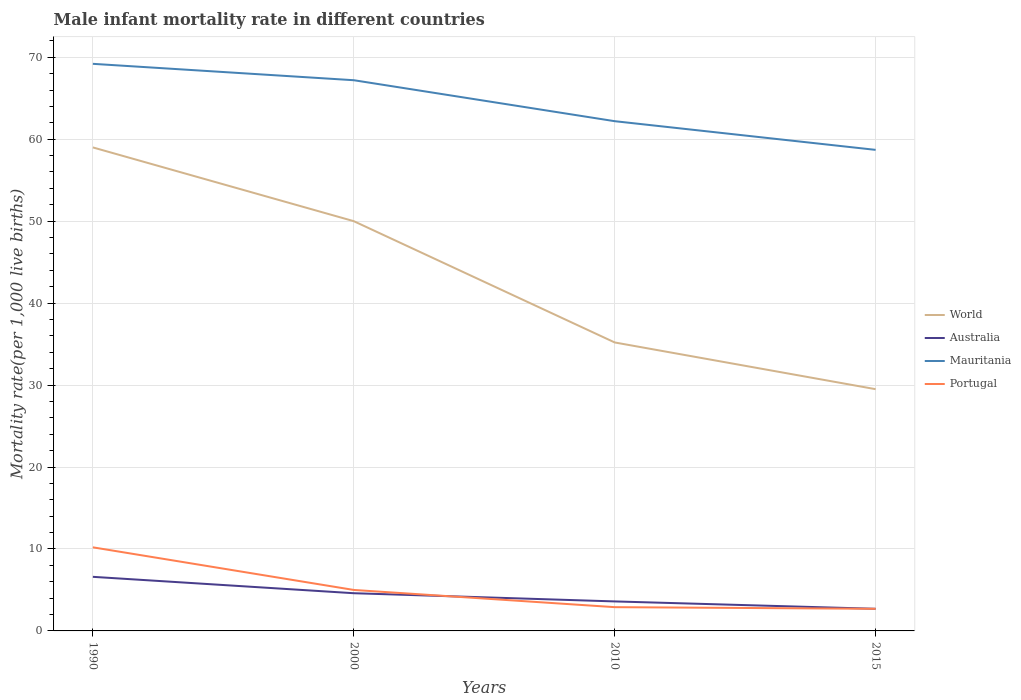How many different coloured lines are there?
Provide a succinct answer. 4. Does the line corresponding to World intersect with the line corresponding to Mauritania?
Offer a terse response. No. Across all years, what is the maximum male infant mortality rate in World?
Your answer should be compact. 29.5. In which year was the male infant mortality rate in Mauritania maximum?
Make the answer very short. 2015. What is the total male infant mortality rate in World in the graph?
Give a very brief answer. 14.8. What is the difference between the highest and the second highest male infant mortality rate in World?
Offer a terse response. 29.5. What is the difference between the highest and the lowest male infant mortality rate in Australia?
Make the answer very short. 2. How many years are there in the graph?
Keep it short and to the point. 4. What is the difference between two consecutive major ticks on the Y-axis?
Provide a short and direct response. 10. Does the graph contain any zero values?
Provide a succinct answer. No. What is the title of the graph?
Keep it short and to the point. Male infant mortality rate in different countries. Does "Gabon" appear as one of the legend labels in the graph?
Your answer should be compact. No. What is the label or title of the Y-axis?
Provide a short and direct response. Mortality rate(per 1,0 live births). What is the Mortality rate(per 1,000 live births) in World in 1990?
Your response must be concise. 59. What is the Mortality rate(per 1,000 live births) in Australia in 1990?
Offer a very short reply. 6.6. What is the Mortality rate(per 1,000 live births) of Mauritania in 1990?
Ensure brevity in your answer.  69.2. What is the Mortality rate(per 1,000 live births) of World in 2000?
Ensure brevity in your answer.  50. What is the Mortality rate(per 1,000 live births) of Australia in 2000?
Make the answer very short. 4.6. What is the Mortality rate(per 1,000 live births) of Mauritania in 2000?
Your response must be concise. 67.2. What is the Mortality rate(per 1,000 live births) in World in 2010?
Your answer should be very brief. 35.2. What is the Mortality rate(per 1,000 live births) in Mauritania in 2010?
Make the answer very short. 62.2. What is the Mortality rate(per 1,000 live births) of Portugal in 2010?
Your answer should be compact. 2.9. What is the Mortality rate(per 1,000 live births) of World in 2015?
Keep it short and to the point. 29.5. What is the Mortality rate(per 1,000 live births) of Australia in 2015?
Offer a very short reply. 2.7. What is the Mortality rate(per 1,000 live births) of Mauritania in 2015?
Your answer should be compact. 58.7. What is the Mortality rate(per 1,000 live births) in Portugal in 2015?
Provide a succinct answer. 2.7. Across all years, what is the maximum Mortality rate(per 1,000 live births) in World?
Your response must be concise. 59. Across all years, what is the maximum Mortality rate(per 1,000 live births) in Mauritania?
Offer a terse response. 69.2. Across all years, what is the maximum Mortality rate(per 1,000 live births) in Portugal?
Ensure brevity in your answer.  10.2. Across all years, what is the minimum Mortality rate(per 1,000 live births) in World?
Your response must be concise. 29.5. Across all years, what is the minimum Mortality rate(per 1,000 live births) of Mauritania?
Your response must be concise. 58.7. Across all years, what is the minimum Mortality rate(per 1,000 live births) of Portugal?
Make the answer very short. 2.7. What is the total Mortality rate(per 1,000 live births) of World in the graph?
Give a very brief answer. 173.7. What is the total Mortality rate(per 1,000 live births) in Mauritania in the graph?
Your answer should be very brief. 257.3. What is the total Mortality rate(per 1,000 live births) of Portugal in the graph?
Offer a terse response. 20.8. What is the difference between the Mortality rate(per 1,000 live births) in Mauritania in 1990 and that in 2000?
Provide a succinct answer. 2. What is the difference between the Mortality rate(per 1,000 live births) of World in 1990 and that in 2010?
Ensure brevity in your answer.  23.8. What is the difference between the Mortality rate(per 1,000 live births) in Mauritania in 1990 and that in 2010?
Provide a succinct answer. 7. What is the difference between the Mortality rate(per 1,000 live births) of World in 1990 and that in 2015?
Your response must be concise. 29.5. What is the difference between the Mortality rate(per 1,000 live births) in World in 2000 and that in 2010?
Your answer should be very brief. 14.8. What is the difference between the Mortality rate(per 1,000 live births) in Australia in 2000 and that in 2010?
Ensure brevity in your answer.  1. What is the difference between the Mortality rate(per 1,000 live births) of Mauritania in 2000 and that in 2010?
Give a very brief answer. 5. What is the difference between the Mortality rate(per 1,000 live births) in World in 2000 and that in 2015?
Keep it short and to the point. 20.5. What is the difference between the Mortality rate(per 1,000 live births) in Australia in 2000 and that in 2015?
Make the answer very short. 1.9. What is the difference between the Mortality rate(per 1,000 live births) of Mauritania in 2000 and that in 2015?
Provide a short and direct response. 8.5. What is the difference between the Mortality rate(per 1,000 live births) of Portugal in 2000 and that in 2015?
Ensure brevity in your answer.  2.3. What is the difference between the Mortality rate(per 1,000 live births) in Australia in 2010 and that in 2015?
Make the answer very short. 0.9. What is the difference between the Mortality rate(per 1,000 live births) of World in 1990 and the Mortality rate(per 1,000 live births) of Australia in 2000?
Give a very brief answer. 54.4. What is the difference between the Mortality rate(per 1,000 live births) of World in 1990 and the Mortality rate(per 1,000 live births) of Portugal in 2000?
Your answer should be compact. 54. What is the difference between the Mortality rate(per 1,000 live births) in Australia in 1990 and the Mortality rate(per 1,000 live births) in Mauritania in 2000?
Make the answer very short. -60.6. What is the difference between the Mortality rate(per 1,000 live births) in Australia in 1990 and the Mortality rate(per 1,000 live births) in Portugal in 2000?
Provide a succinct answer. 1.6. What is the difference between the Mortality rate(per 1,000 live births) of Mauritania in 1990 and the Mortality rate(per 1,000 live births) of Portugal in 2000?
Your response must be concise. 64.2. What is the difference between the Mortality rate(per 1,000 live births) in World in 1990 and the Mortality rate(per 1,000 live births) in Australia in 2010?
Your response must be concise. 55.4. What is the difference between the Mortality rate(per 1,000 live births) of World in 1990 and the Mortality rate(per 1,000 live births) of Portugal in 2010?
Your answer should be compact. 56.1. What is the difference between the Mortality rate(per 1,000 live births) in Australia in 1990 and the Mortality rate(per 1,000 live births) in Mauritania in 2010?
Offer a terse response. -55.6. What is the difference between the Mortality rate(per 1,000 live births) in Australia in 1990 and the Mortality rate(per 1,000 live births) in Portugal in 2010?
Your answer should be compact. 3.7. What is the difference between the Mortality rate(per 1,000 live births) in Mauritania in 1990 and the Mortality rate(per 1,000 live births) in Portugal in 2010?
Ensure brevity in your answer.  66.3. What is the difference between the Mortality rate(per 1,000 live births) of World in 1990 and the Mortality rate(per 1,000 live births) of Australia in 2015?
Keep it short and to the point. 56.3. What is the difference between the Mortality rate(per 1,000 live births) in World in 1990 and the Mortality rate(per 1,000 live births) in Mauritania in 2015?
Offer a terse response. 0.3. What is the difference between the Mortality rate(per 1,000 live births) of World in 1990 and the Mortality rate(per 1,000 live births) of Portugal in 2015?
Give a very brief answer. 56.3. What is the difference between the Mortality rate(per 1,000 live births) of Australia in 1990 and the Mortality rate(per 1,000 live births) of Mauritania in 2015?
Ensure brevity in your answer.  -52.1. What is the difference between the Mortality rate(per 1,000 live births) of Mauritania in 1990 and the Mortality rate(per 1,000 live births) of Portugal in 2015?
Provide a short and direct response. 66.5. What is the difference between the Mortality rate(per 1,000 live births) of World in 2000 and the Mortality rate(per 1,000 live births) of Australia in 2010?
Make the answer very short. 46.4. What is the difference between the Mortality rate(per 1,000 live births) of World in 2000 and the Mortality rate(per 1,000 live births) of Mauritania in 2010?
Provide a succinct answer. -12.2. What is the difference between the Mortality rate(per 1,000 live births) in World in 2000 and the Mortality rate(per 1,000 live births) in Portugal in 2010?
Offer a very short reply. 47.1. What is the difference between the Mortality rate(per 1,000 live births) in Australia in 2000 and the Mortality rate(per 1,000 live births) in Mauritania in 2010?
Make the answer very short. -57.6. What is the difference between the Mortality rate(per 1,000 live births) in Mauritania in 2000 and the Mortality rate(per 1,000 live births) in Portugal in 2010?
Ensure brevity in your answer.  64.3. What is the difference between the Mortality rate(per 1,000 live births) of World in 2000 and the Mortality rate(per 1,000 live births) of Australia in 2015?
Offer a terse response. 47.3. What is the difference between the Mortality rate(per 1,000 live births) in World in 2000 and the Mortality rate(per 1,000 live births) in Mauritania in 2015?
Make the answer very short. -8.7. What is the difference between the Mortality rate(per 1,000 live births) of World in 2000 and the Mortality rate(per 1,000 live births) of Portugal in 2015?
Offer a terse response. 47.3. What is the difference between the Mortality rate(per 1,000 live births) in Australia in 2000 and the Mortality rate(per 1,000 live births) in Mauritania in 2015?
Give a very brief answer. -54.1. What is the difference between the Mortality rate(per 1,000 live births) of Mauritania in 2000 and the Mortality rate(per 1,000 live births) of Portugal in 2015?
Your answer should be compact. 64.5. What is the difference between the Mortality rate(per 1,000 live births) of World in 2010 and the Mortality rate(per 1,000 live births) of Australia in 2015?
Ensure brevity in your answer.  32.5. What is the difference between the Mortality rate(per 1,000 live births) in World in 2010 and the Mortality rate(per 1,000 live births) in Mauritania in 2015?
Ensure brevity in your answer.  -23.5. What is the difference between the Mortality rate(per 1,000 live births) in World in 2010 and the Mortality rate(per 1,000 live births) in Portugal in 2015?
Provide a short and direct response. 32.5. What is the difference between the Mortality rate(per 1,000 live births) in Australia in 2010 and the Mortality rate(per 1,000 live births) in Mauritania in 2015?
Provide a succinct answer. -55.1. What is the difference between the Mortality rate(per 1,000 live births) of Mauritania in 2010 and the Mortality rate(per 1,000 live births) of Portugal in 2015?
Your answer should be compact. 59.5. What is the average Mortality rate(per 1,000 live births) in World per year?
Offer a very short reply. 43.42. What is the average Mortality rate(per 1,000 live births) of Australia per year?
Offer a terse response. 4.38. What is the average Mortality rate(per 1,000 live births) of Mauritania per year?
Offer a very short reply. 64.33. What is the average Mortality rate(per 1,000 live births) of Portugal per year?
Provide a succinct answer. 5.2. In the year 1990, what is the difference between the Mortality rate(per 1,000 live births) of World and Mortality rate(per 1,000 live births) of Australia?
Provide a short and direct response. 52.4. In the year 1990, what is the difference between the Mortality rate(per 1,000 live births) in World and Mortality rate(per 1,000 live births) in Mauritania?
Keep it short and to the point. -10.2. In the year 1990, what is the difference between the Mortality rate(per 1,000 live births) in World and Mortality rate(per 1,000 live births) in Portugal?
Ensure brevity in your answer.  48.8. In the year 1990, what is the difference between the Mortality rate(per 1,000 live births) in Australia and Mortality rate(per 1,000 live births) in Mauritania?
Make the answer very short. -62.6. In the year 2000, what is the difference between the Mortality rate(per 1,000 live births) in World and Mortality rate(per 1,000 live births) in Australia?
Your response must be concise. 45.4. In the year 2000, what is the difference between the Mortality rate(per 1,000 live births) of World and Mortality rate(per 1,000 live births) of Mauritania?
Provide a succinct answer. -17.2. In the year 2000, what is the difference between the Mortality rate(per 1,000 live births) of Australia and Mortality rate(per 1,000 live births) of Mauritania?
Provide a succinct answer. -62.6. In the year 2000, what is the difference between the Mortality rate(per 1,000 live births) in Mauritania and Mortality rate(per 1,000 live births) in Portugal?
Your response must be concise. 62.2. In the year 2010, what is the difference between the Mortality rate(per 1,000 live births) in World and Mortality rate(per 1,000 live births) in Australia?
Your answer should be compact. 31.6. In the year 2010, what is the difference between the Mortality rate(per 1,000 live births) of World and Mortality rate(per 1,000 live births) of Portugal?
Your response must be concise. 32.3. In the year 2010, what is the difference between the Mortality rate(per 1,000 live births) of Australia and Mortality rate(per 1,000 live births) of Mauritania?
Keep it short and to the point. -58.6. In the year 2010, what is the difference between the Mortality rate(per 1,000 live births) of Mauritania and Mortality rate(per 1,000 live births) of Portugal?
Offer a terse response. 59.3. In the year 2015, what is the difference between the Mortality rate(per 1,000 live births) in World and Mortality rate(per 1,000 live births) in Australia?
Provide a short and direct response. 26.8. In the year 2015, what is the difference between the Mortality rate(per 1,000 live births) in World and Mortality rate(per 1,000 live births) in Mauritania?
Provide a succinct answer. -29.2. In the year 2015, what is the difference between the Mortality rate(per 1,000 live births) of World and Mortality rate(per 1,000 live births) of Portugal?
Your response must be concise. 26.8. In the year 2015, what is the difference between the Mortality rate(per 1,000 live births) of Australia and Mortality rate(per 1,000 live births) of Mauritania?
Provide a short and direct response. -56. In the year 2015, what is the difference between the Mortality rate(per 1,000 live births) in Mauritania and Mortality rate(per 1,000 live births) in Portugal?
Make the answer very short. 56. What is the ratio of the Mortality rate(per 1,000 live births) of World in 1990 to that in 2000?
Offer a very short reply. 1.18. What is the ratio of the Mortality rate(per 1,000 live births) in Australia in 1990 to that in 2000?
Your answer should be compact. 1.43. What is the ratio of the Mortality rate(per 1,000 live births) of Mauritania in 1990 to that in 2000?
Ensure brevity in your answer.  1.03. What is the ratio of the Mortality rate(per 1,000 live births) in Portugal in 1990 to that in 2000?
Your response must be concise. 2.04. What is the ratio of the Mortality rate(per 1,000 live births) of World in 1990 to that in 2010?
Your answer should be very brief. 1.68. What is the ratio of the Mortality rate(per 1,000 live births) in Australia in 1990 to that in 2010?
Provide a succinct answer. 1.83. What is the ratio of the Mortality rate(per 1,000 live births) in Mauritania in 1990 to that in 2010?
Provide a succinct answer. 1.11. What is the ratio of the Mortality rate(per 1,000 live births) of Portugal in 1990 to that in 2010?
Provide a short and direct response. 3.52. What is the ratio of the Mortality rate(per 1,000 live births) of Australia in 1990 to that in 2015?
Your answer should be compact. 2.44. What is the ratio of the Mortality rate(per 1,000 live births) in Mauritania in 1990 to that in 2015?
Offer a very short reply. 1.18. What is the ratio of the Mortality rate(per 1,000 live births) in Portugal in 1990 to that in 2015?
Your response must be concise. 3.78. What is the ratio of the Mortality rate(per 1,000 live births) in World in 2000 to that in 2010?
Ensure brevity in your answer.  1.42. What is the ratio of the Mortality rate(per 1,000 live births) in Australia in 2000 to that in 2010?
Your answer should be very brief. 1.28. What is the ratio of the Mortality rate(per 1,000 live births) in Mauritania in 2000 to that in 2010?
Your answer should be compact. 1.08. What is the ratio of the Mortality rate(per 1,000 live births) of Portugal in 2000 to that in 2010?
Make the answer very short. 1.72. What is the ratio of the Mortality rate(per 1,000 live births) in World in 2000 to that in 2015?
Provide a succinct answer. 1.69. What is the ratio of the Mortality rate(per 1,000 live births) of Australia in 2000 to that in 2015?
Offer a terse response. 1.7. What is the ratio of the Mortality rate(per 1,000 live births) of Mauritania in 2000 to that in 2015?
Give a very brief answer. 1.14. What is the ratio of the Mortality rate(per 1,000 live births) in Portugal in 2000 to that in 2015?
Your response must be concise. 1.85. What is the ratio of the Mortality rate(per 1,000 live births) in World in 2010 to that in 2015?
Give a very brief answer. 1.19. What is the ratio of the Mortality rate(per 1,000 live births) of Australia in 2010 to that in 2015?
Your answer should be compact. 1.33. What is the ratio of the Mortality rate(per 1,000 live births) of Mauritania in 2010 to that in 2015?
Give a very brief answer. 1.06. What is the ratio of the Mortality rate(per 1,000 live births) in Portugal in 2010 to that in 2015?
Give a very brief answer. 1.07. What is the difference between the highest and the second highest Mortality rate(per 1,000 live births) in World?
Keep it short and to the point. 9. What is the difference between the highest and the second highest Mortality rate(per 1,000 live births) of Portugal?
Your answer should be very brief. 5.2. What is the difference between the highest and the lowest Mortality rate(per 1,000 live births) of World?
Keep it short and to the point. 29.5. What is the difference between the highest and the lowest Mortality rate(per 1,000 live births) in Australia?
Provide a short and direct response. 3.9. What is the difference between the highest and the lowest Mortality rate(per 1,000 live births) of Mauritania?
Ensure brevity in your answer.  10.5. 